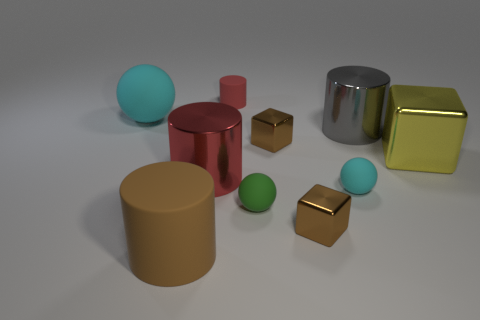Subtract all gray spheres. Subtract all blue cylinders. How many spheres are left? 3 Subtract all blocks. How many objects are left? 7 Subtract 0 red balls. How many objects are left? 10 Subtract all big yellow metallic cubes. Subtract all big brown rubber objects. How many objects are left? 8 Add 7 matte spheres. How many matte spheres are left? 10 Add 1 brown cylinders. How many brown cylinders exist? 2 